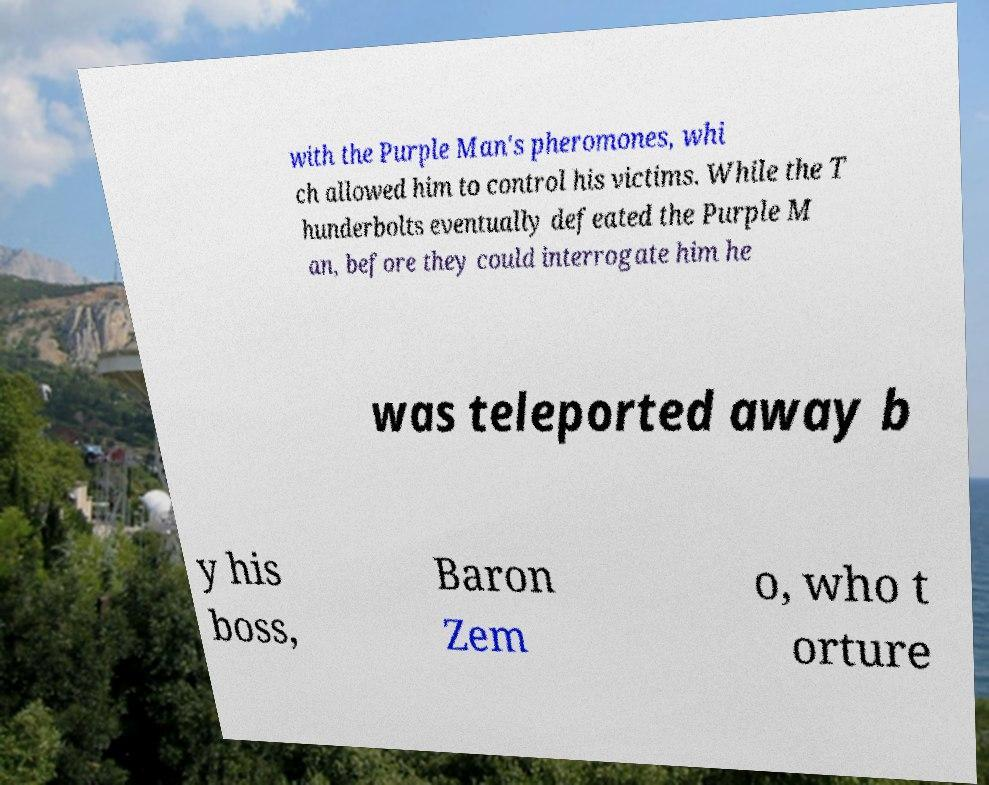Could you assist in decoding the text presented in this image and type it out clearly? with the Purple Man's pheromones, whi ch allowed him to control his victims. While the T hunderbolts eventually defeated the Purple M an, before they could interrogate him he was teleported away b y his boss, Baron Zem o, who t orture 